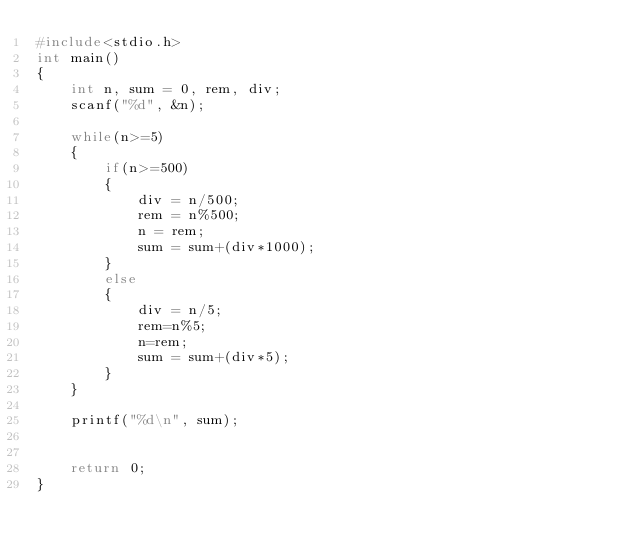<code> <loc_0><loc_0><loc_500><loc_500><_C_>#include<stdio.h>
int main()
{
    int n, sum = 0, rem, div;
    scanf("%d", &n);

    while(n>=5)
    {
        if(n>=500)
        {
            div = n/500;
            rem = n%500;
            n = rem;
            sum = sum+(div*1000);
        }
        else
        {
            div = n/5;
            rem=n%5;
            n=rem;
            sum = sum+(div*5);
        }
    }

    printf("%d\n", sum);


    return 0;
}
</code> 